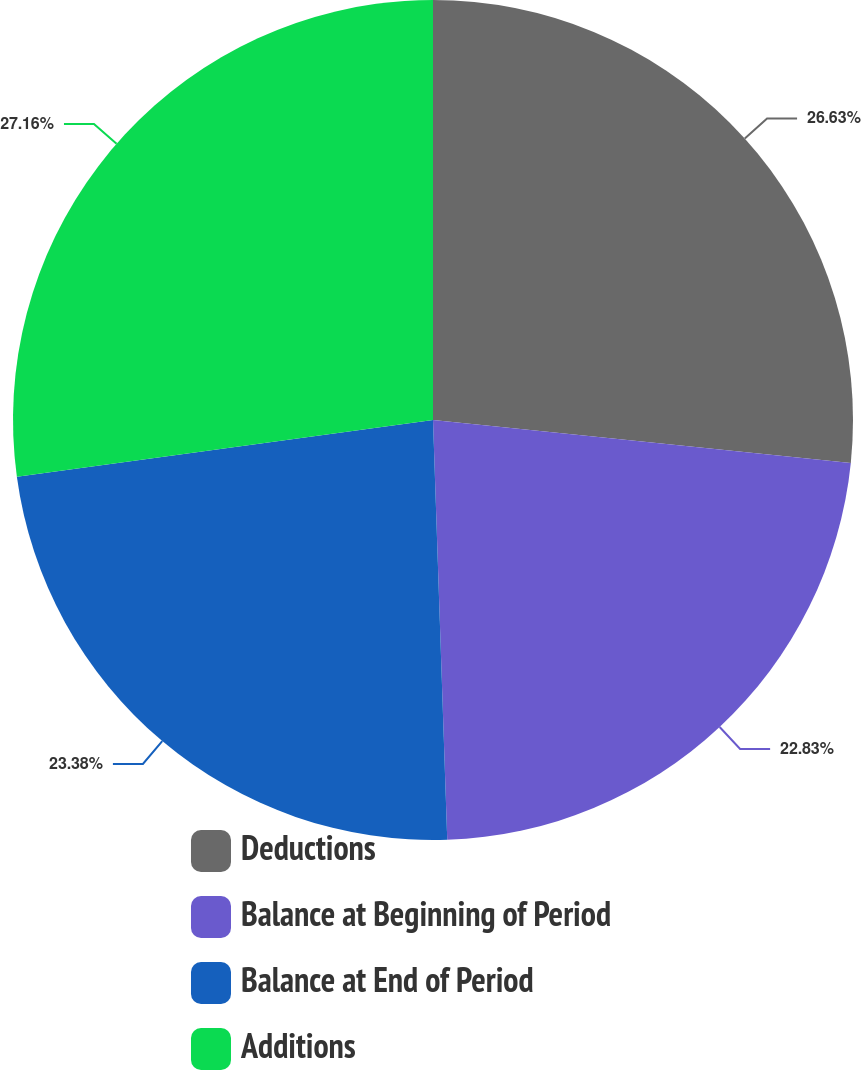Convert chart to OTSL. <chart><loc_0><loc_0><loc_500><loc_500><pie_chart><fcel>Deductions<fcel>Balance at Beginning of Period<fcel>Balance at End of Period<fcel>Additions<nl><fcel>26.63%<fcel>22.83%<fcel>23.38%<fcel>27.16%<nl></chart> 